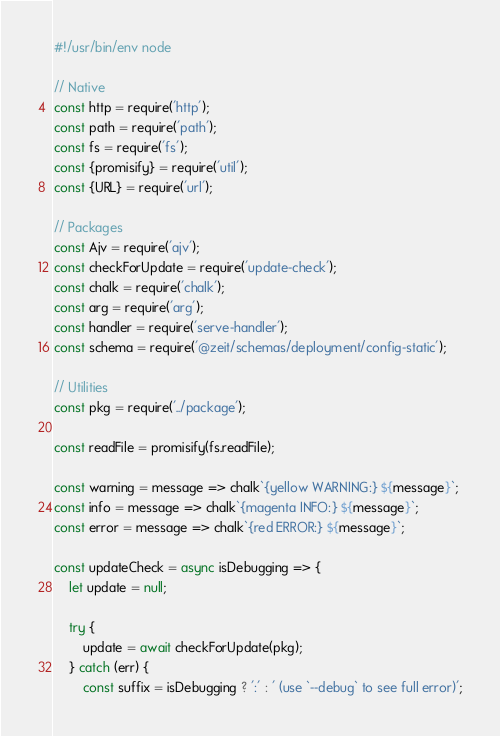Convert code to text. <code><loc_0><loc_0><loc_500><loc_500><_JavaScript_>#!/usr/bin/env node

// Native
const http = require('http');
const path = require('path');
const fs = require('fs');
const {promisify} = require('util');
const {URL} = require('url');

// Packages
const Ajv = require('ajv');
const checkForUpdate = require('update-check');
const chalk = require('chalk');
const arg = require('arg');
const handler = require('serve-handler');
const schema = require('@zeit/schemas/deployment/config-static');

// Utilities
const pkg = require('../package');

const readFile = promisify(fs.readFile);

const warning = message => chalk`{yellow WARNING:} ${message}`;
const info = message => chalk`{magenta INFO:} ${message}`;
const error = message => chalk`{red ERROR:} ${message}`;

const updateCheck = async isDebugging => {
	let update = null;

	try {
		update = await checkForUpdate(pkg);
	} catch (err) {
		const suffix = isDebugging ? ':' : ' (use `--debug` to see full error)';</code> 